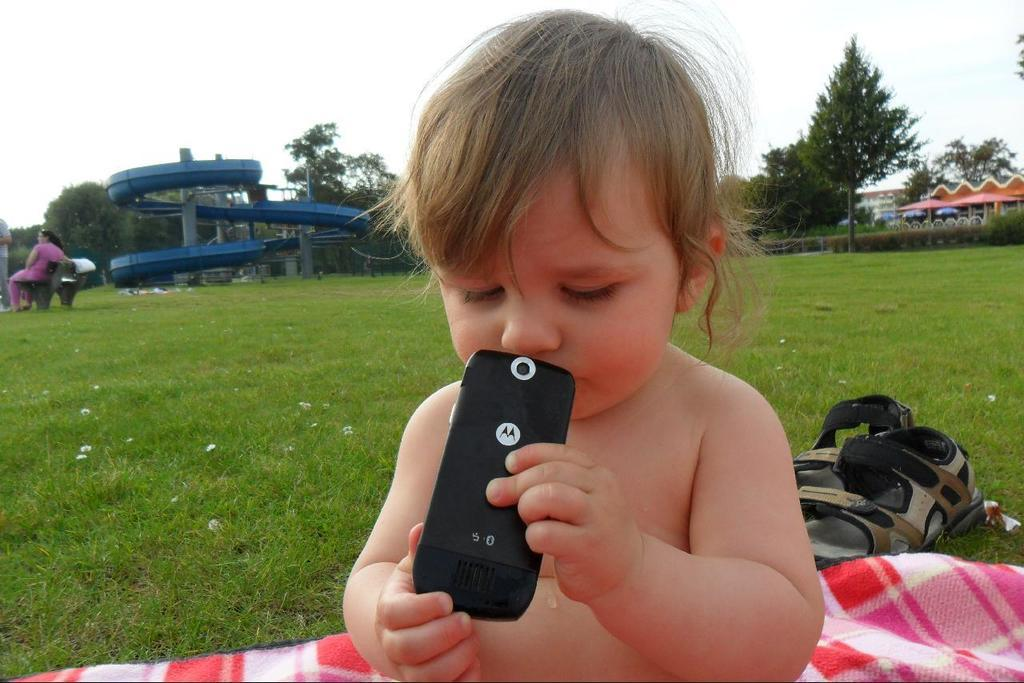What is the baby holding in the image? The small baby is holding a mobile in the image. What can be seen on the grass lawn in the image? There is a check towel chapel on the grass lawn in the image. What is visible in the background of the image? Trees, the sky, a bench, and a rider are visible in the background of the image. Can you describe the lady's position in the image? A lady is sitting on the bench in the background of the image. Is there a lake visible in the image? No, there is no lake present in the image. Is the lady acting as a spy in the image? There is no indication in the image that the lady is a spy, and her actions are not described. 